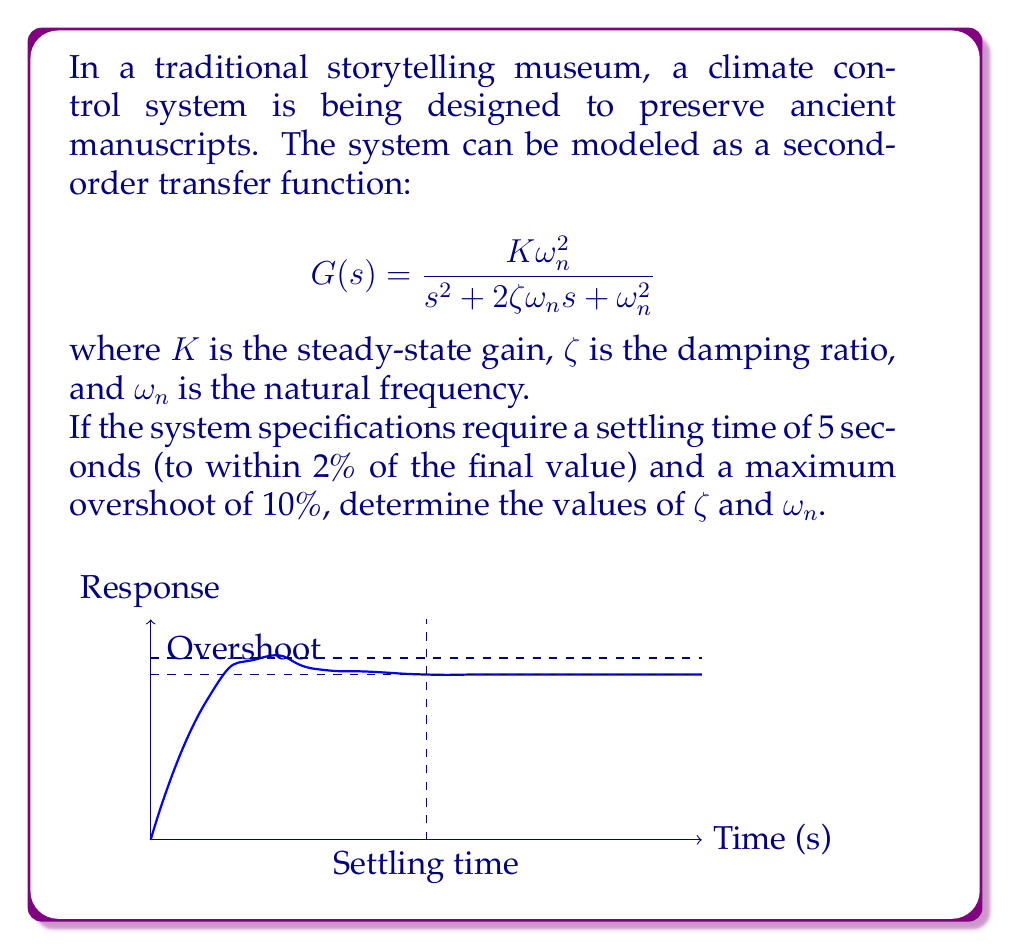Help me with this question. Let's approach this step-by-step:

1) For a second-order system, the settling time $t_s$ (to within 2% of final value) is given by:

   $$t_s \approx \frac{4}{\zeta\omega_n}$$

2) The maximum overshoot $M_p$ is related to the damping ratio $\zeta$ by:

   $$M_p = e^{-\pi\zeta/\sqrt{1-\zeta^2}} \times 100\%$$

3) From the given specifications:
   $t_s = 5$ seconds
   $M_p = 10\% = 0.1$

4) Using the overshoot equation:

   $$0.1 = e^{-\pi\zeta/\sqrt{1-\zeta^2}}$$

   Taking natural log of both sides:

   $$\ln(0.1) = -\pi\zeta/\sqrt{1-\zeta^2}$$

   Solving this numerically (or using tables), we get:

   $$\zeta \approx 0.591$$

5) Now, using the settling time equation:

   $$5 = \frac{4}{\zeta\omega_n}$$

   Substituting the value of $\zeta$:

   $$5 = \frac{4}{0.591\omega_n}$$

   Solving for $\omega_n$:

   $$\omega_n = \frac{4}{5 \times 0.591} \approx 1.354 \text{ rad/s}$$

Therefore, we have found the values of $\zeta$ and $\omega_n$ that meet the given specifications.
Answer: $\zeta \approx 0.591$, $\omega_n \approx 1.354 \text{ rad/s}$ 